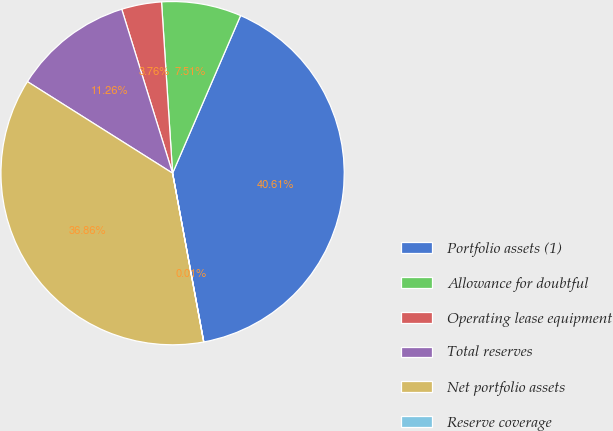Convert chart to OTSL. <chart><loc_0><loc_0><loc_500><loc_500><pie_chart><fcel>Portfolio assets (1)<fcel>Allowance for doubtful<fcel>Operating lease equipment<fcel>Total reserves<fcel>Net portfolio assets<fcel>Reserve coverage<nl><fcel>40.61%<fcel>7.51%<fcel>3.76%<fcel>11.26%<fcel>36.86%<fcel>0.01%<nl></chart> 